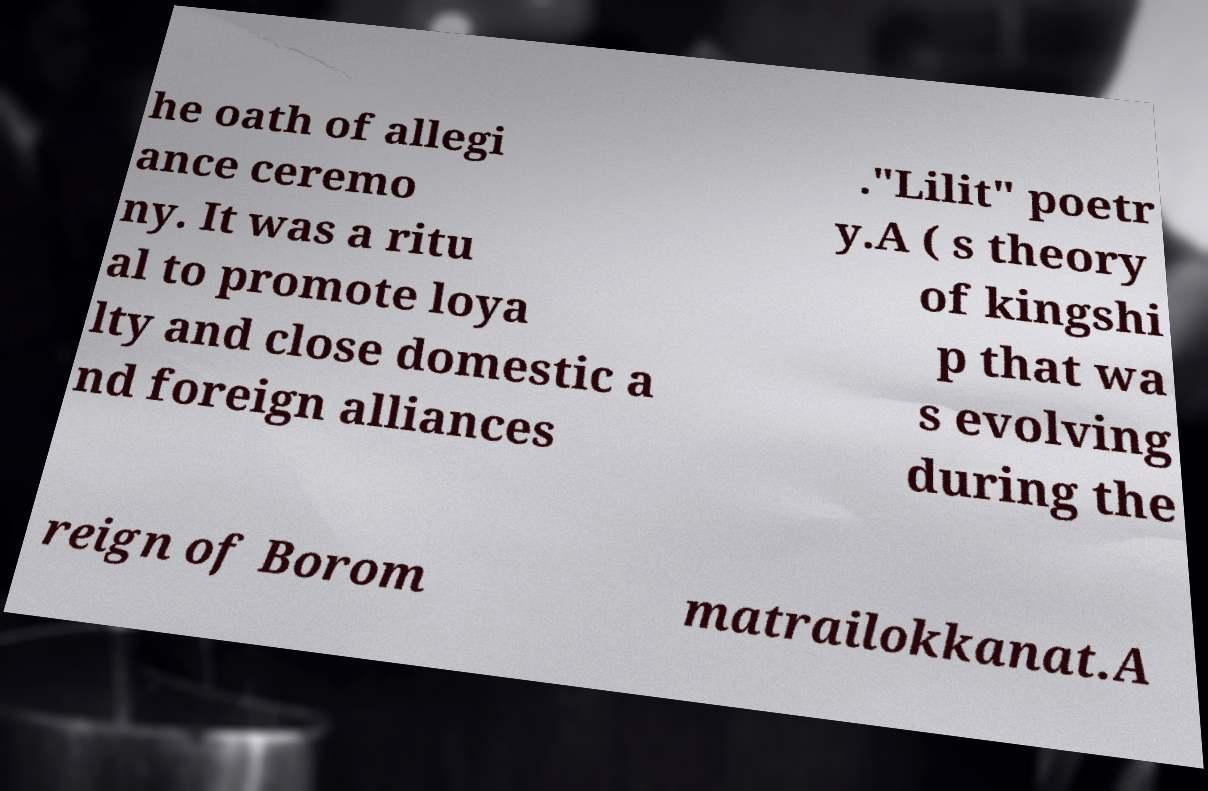What messages or text are displayed in this image? I need them in a readable, typed format. he oath of allegi ance ceremo ny. It was a ritu al to promote loya lty and close domestic a nd foreign alliances ."Lilit" poetr y.A ( s theory of kingshi p that wa s evolving during the reign of Borom matrailokkanat.A 